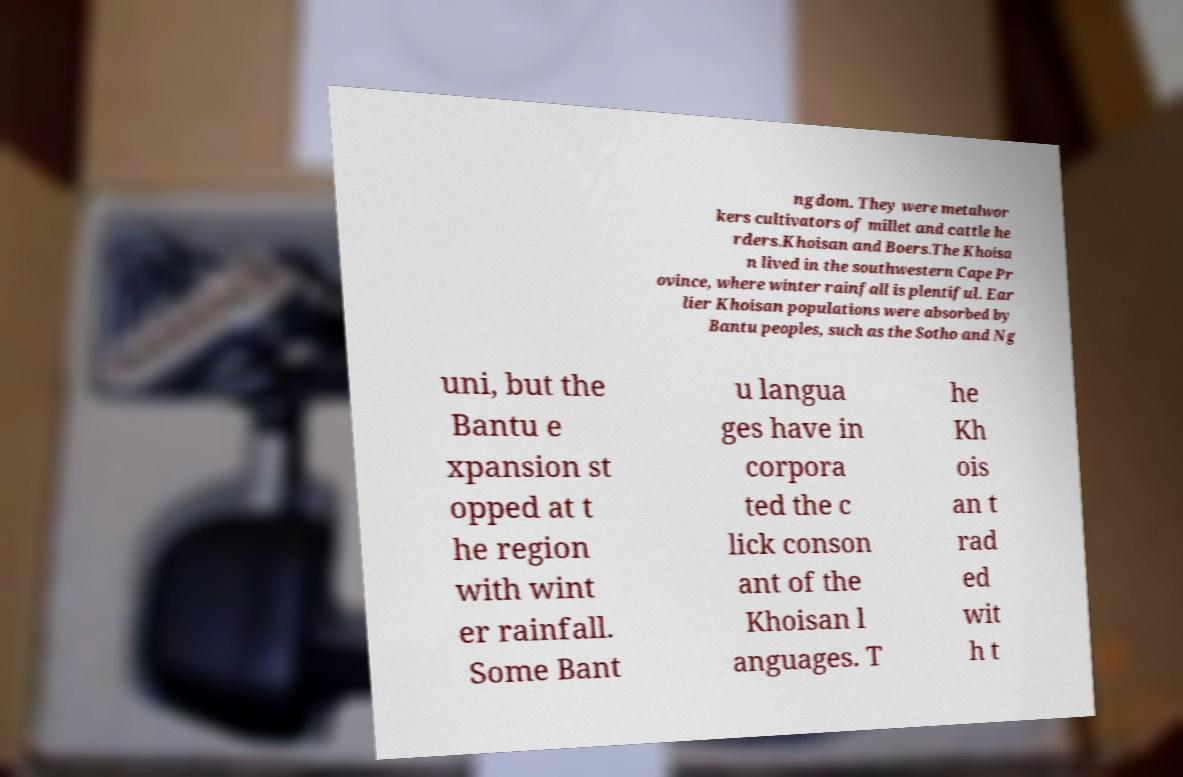Can you accurately transcribe the text from the provided image for me? ngdom. They were metalwor kers cultivators of millet and cattle he rders.Khoisan and Boers.The Khoisa n lived in the southwestern Cape Pr ovince, where winter rainfall is plentiful. Ear lier Khoisan populations were absorbed by Bantu peoples, such as the Sotho and Ng uni, but the Bantu e xpansion st opped at t he region with wint er rainfall. Some Bant u langua ges have in corpora ted the c lick conson ant of the Khoisan l anguages. T he Kh ois an t rad ed wit h t 